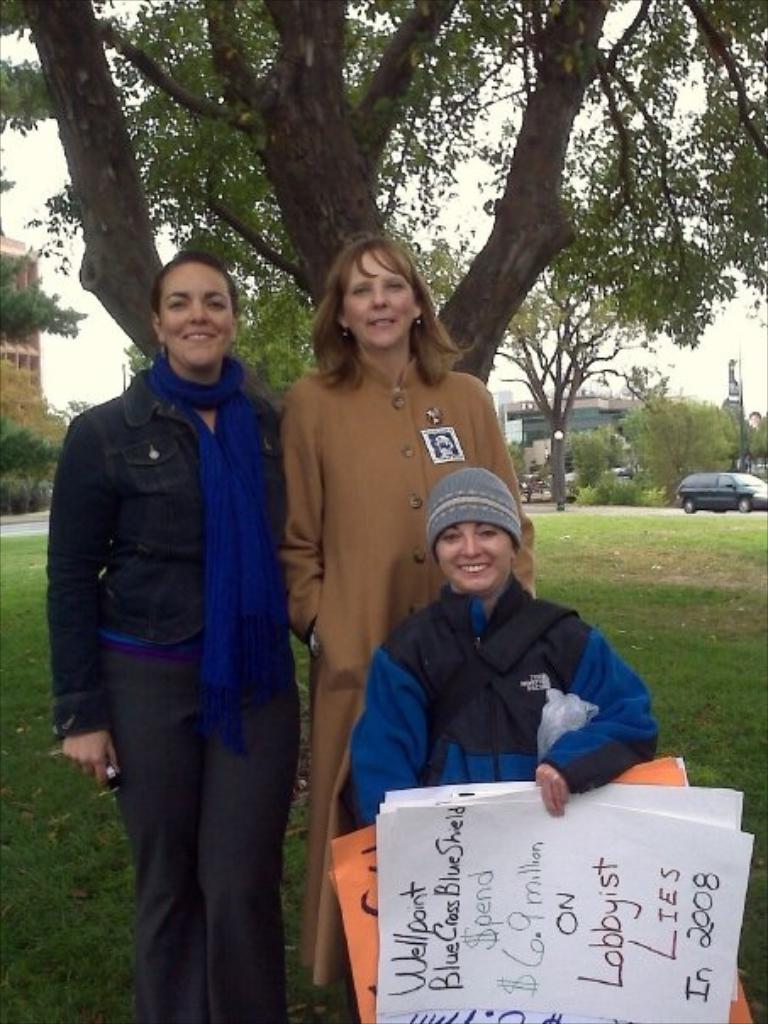In one or two sentences, can you explain what this image depicts? In this image we can see three ladies are standing and one lady is holding papers in her hand. In the background of the image we can see trees and car. 